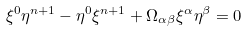Convert formula to latex. <formula><loc_0><loc_0><loc_500><loc_500>\xi ^ { 0 } \eta ^ { n + 1 } - \eta ^ { 0 } \xi ^ { n + 1 } + \Omega _ { \alpha \beta } \xi ^ { \alpha } \eta ^ { \beta } = 0</formula> 